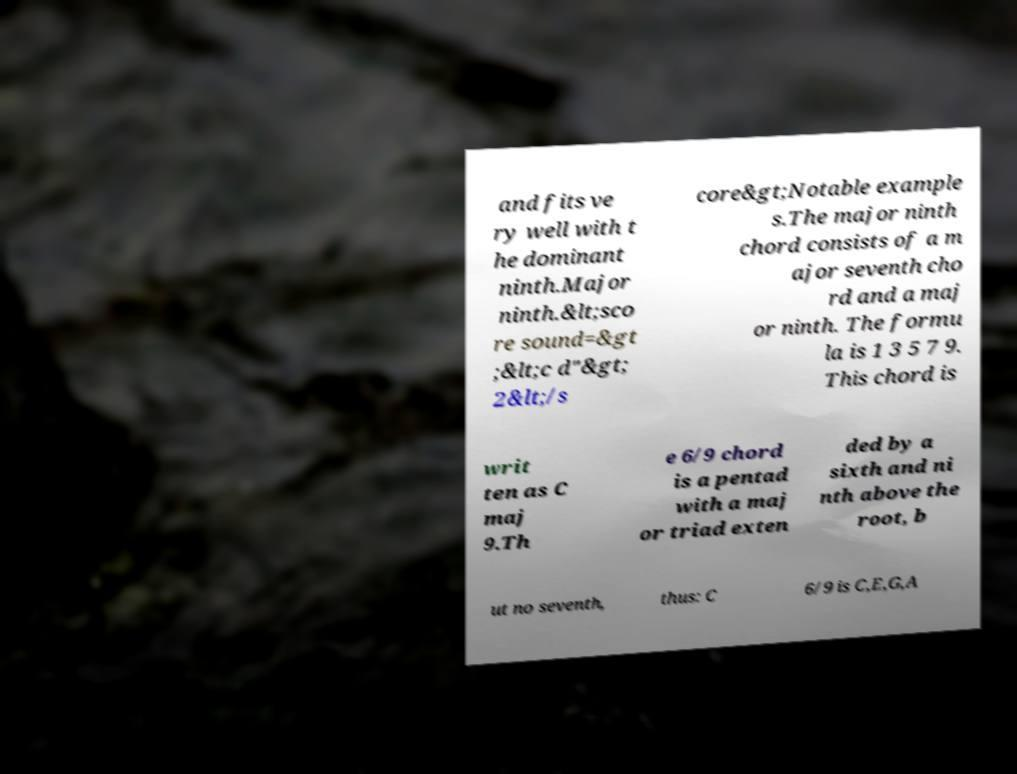Please read and relay the text visible in this image. What does it say? and fits ve ry well with t he dominant ninth.Major ninth.&lt;sco re sound=&gt ;&lt;c d"&gt; 2&lt;/s core&gt;Notable example s.The major ninth chord consists of a m ajor seventh cho rd and a maj or ninth. The formu la is 1 3 5 7 9. This chord is writ ten as C maj 9.Th e 6/9 chord is a pentad with a maj or triad exten ded by a sixth and ni nth above the root, b ut no seventh, thus: C 6/9 is C,E,G,A 